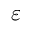<formula> <loc_0><loc_0><loc_500><loc_500>\varepsilon</formula> 